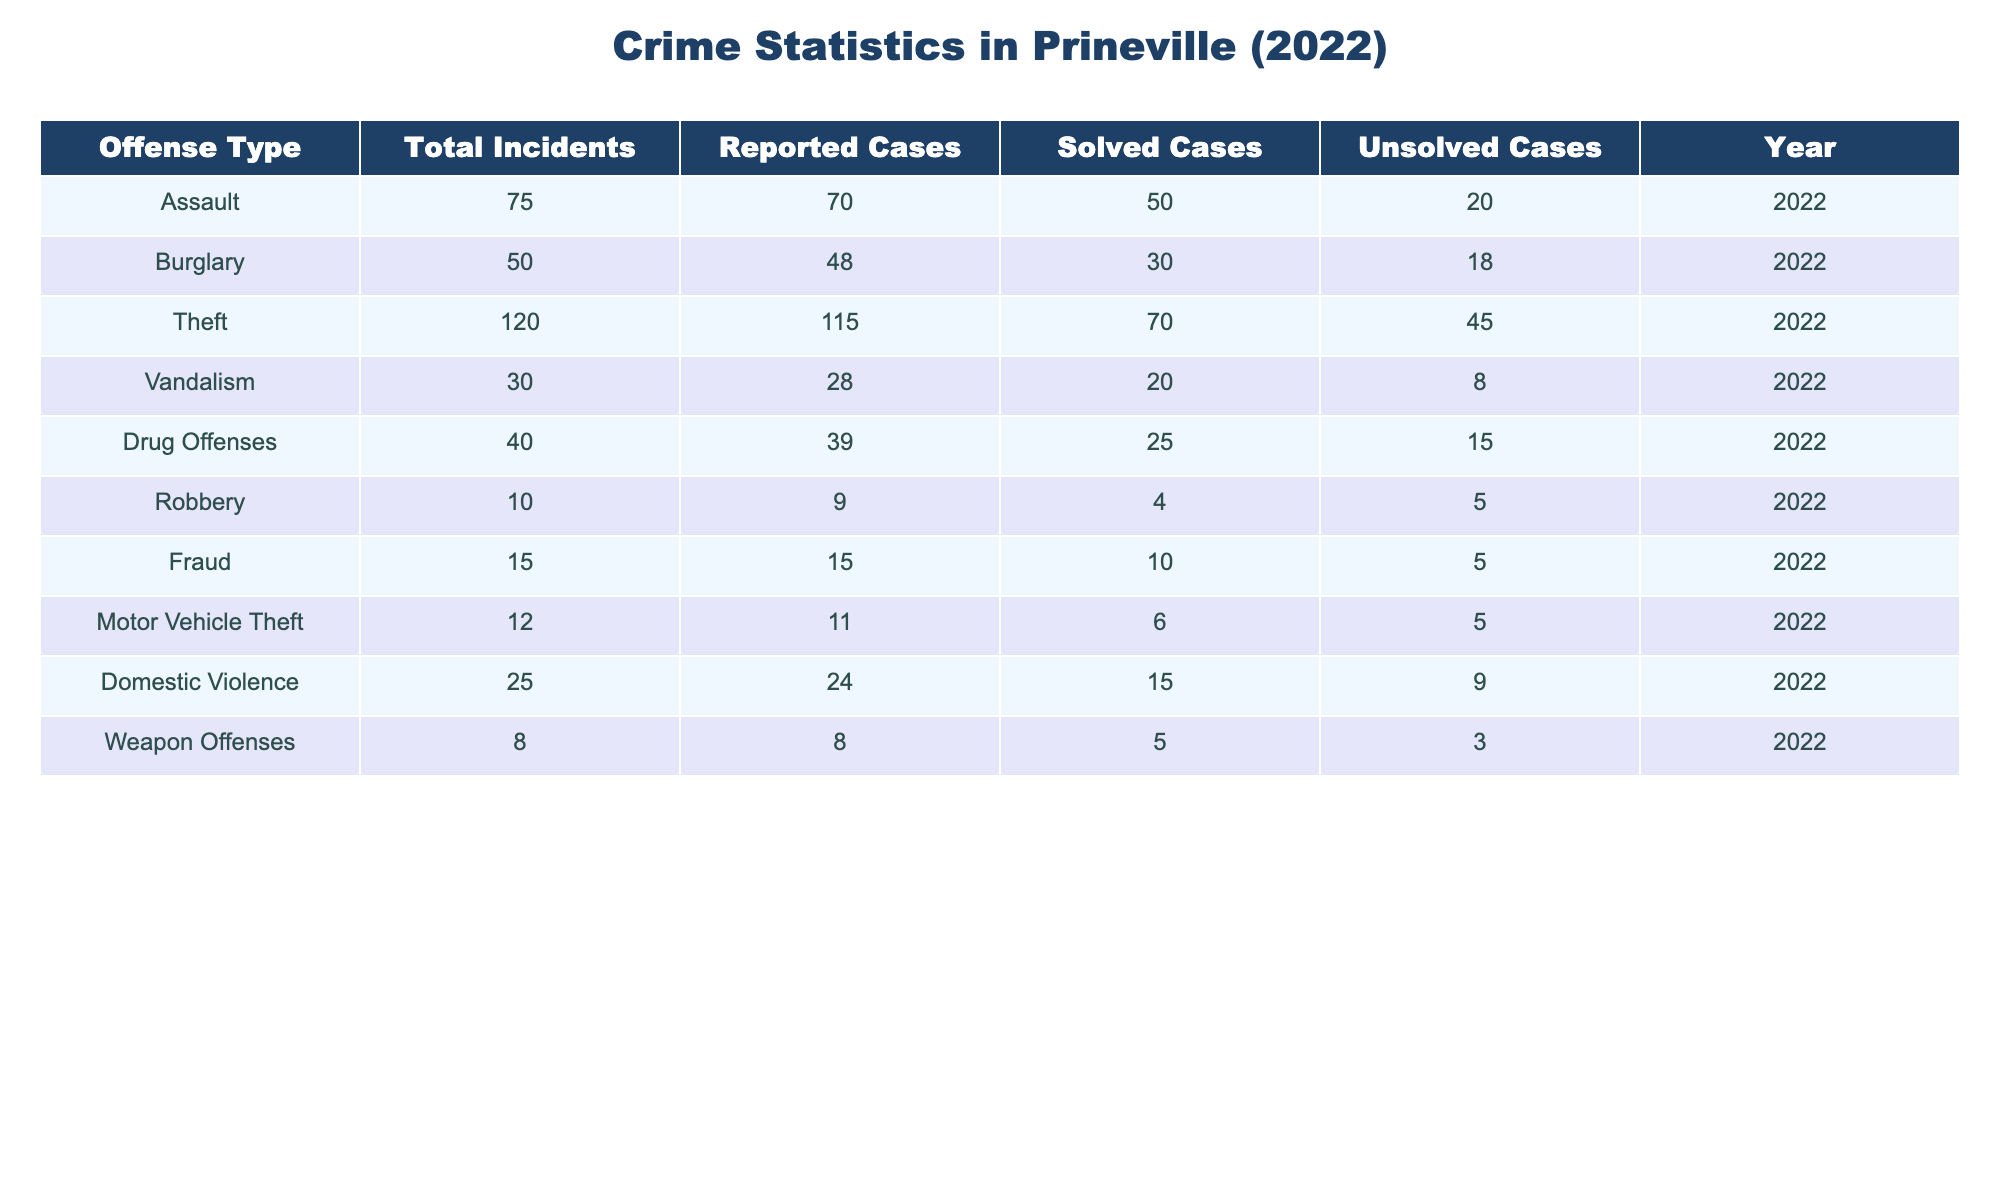What's the total number of incidents reported for Theft? Referring to the table, the Total Incidents column indicates there were 120 reported for the Theft offense type.
Answer: 120 How many solved cases were there for Drug Offenses? Looking at the Drug Offenses row, the Solved Cases column shows that there were 25 solved cases.
Answer: 25 Which offense had the highest number of unsolved cases? By examining the Unsolved Cases column, Theft had the highest value of 45.
Answer: Theft What is the difference in the number of total incidents between Assault and Burglary? Total Incidents for Assault is 75, and for Burglary, it is 50. The difference is 75 - 50 = 25.
Answer: 25 How many total incidents were reported for Domestic Violence and Weapon Offenses combined? Adding the Total Incidents for Domestic Violence (25) and Weapon Offenses (8) gives 25 + 8 = 33.
Answer: 33 Is the number of solved cases for Burglary greater than or equal to the solved cases for Domestic Violence? Burglary has 30 solved cases, while Domestic Violence has 15. Thus, 30 is greater than 15, confirming the statement is true.
Answer: Yes What percentage of theft cases were solved? To calculate the percentage of solved cases for Theft, divide the number of solved cases (70) by the total number of incidents (120) and multiply by 100. Thus, (70/120) * 100 = 58.33%.
Answer: 58.33% If you combine all unsolved cases, what is the total? Adding the number of unsolved cases from all offenses: 20 (Assault) + 18 (Burglary) + 45 (Theft) + 8 (Vandalism) + 15 (Drug Offenses) + 5 (Robbery) + 5 (Fraud) + 5 (Motor Vehicle Theft) + 9 (Domestic Violence) + 3 (Weapon Offenses) results in a total of 128 unsolved cases.
Answer: 128 What was the ratio of Solved Cases to Total Incidents for Vandalism? The ratio can be calculated by taking the Solved Cases (20) over Total Incidents (30): 20:30, which simplifies to 2:3.
Answer: 2:3 Which offense type had the least number of total incidents? By checking the Total Incidents column, Weapon Offenses shows the least number with only 8 incidents reported.
Answer: Weapon Offenses 